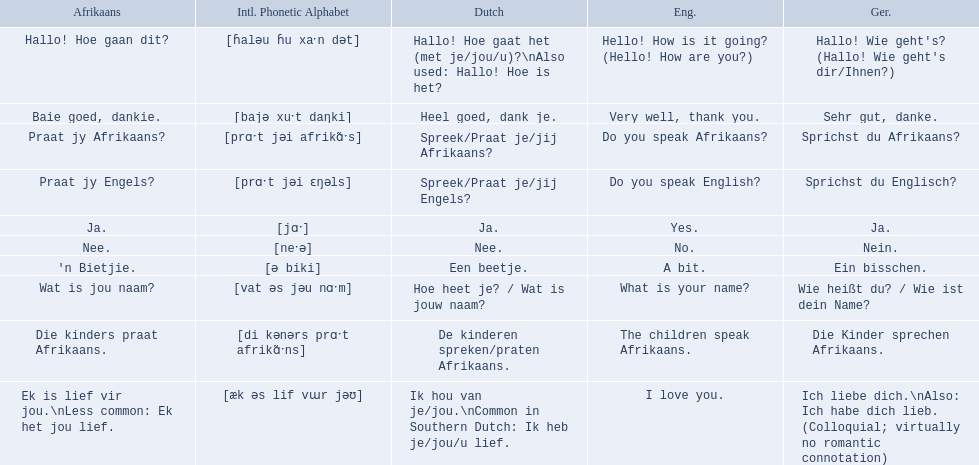How do you say do you speak english in german? Sprichst du Englisch?. What about do you speak afrikaanss? in afrikaans? Praat jy Afrikaans?. 